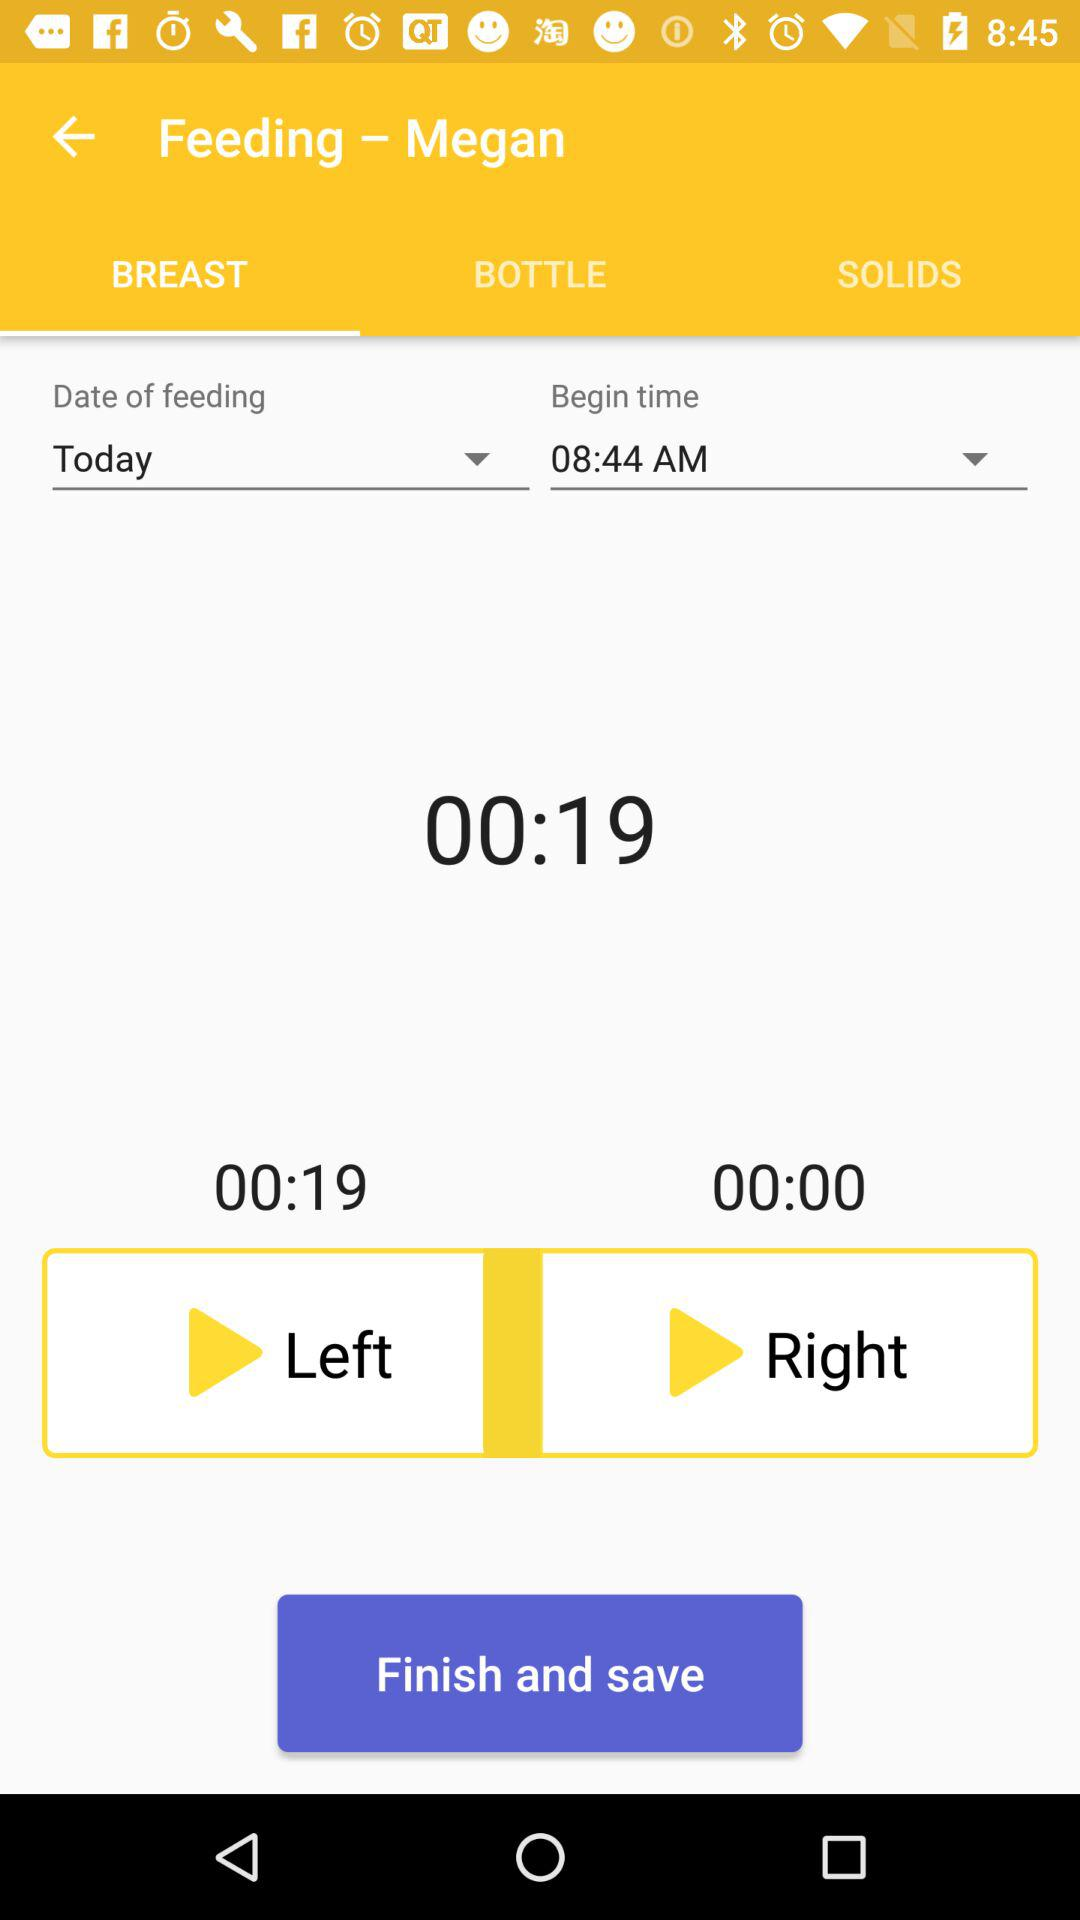How long is the feeding?
Answer the question using a single word or phrase. 00:19 